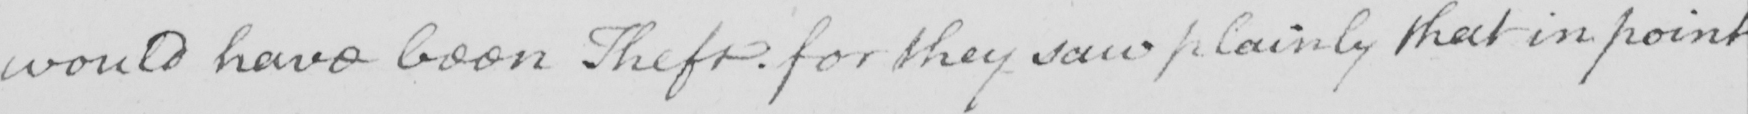What is written in this line of handwriting? would have been Theft for they saw plainly that in point 